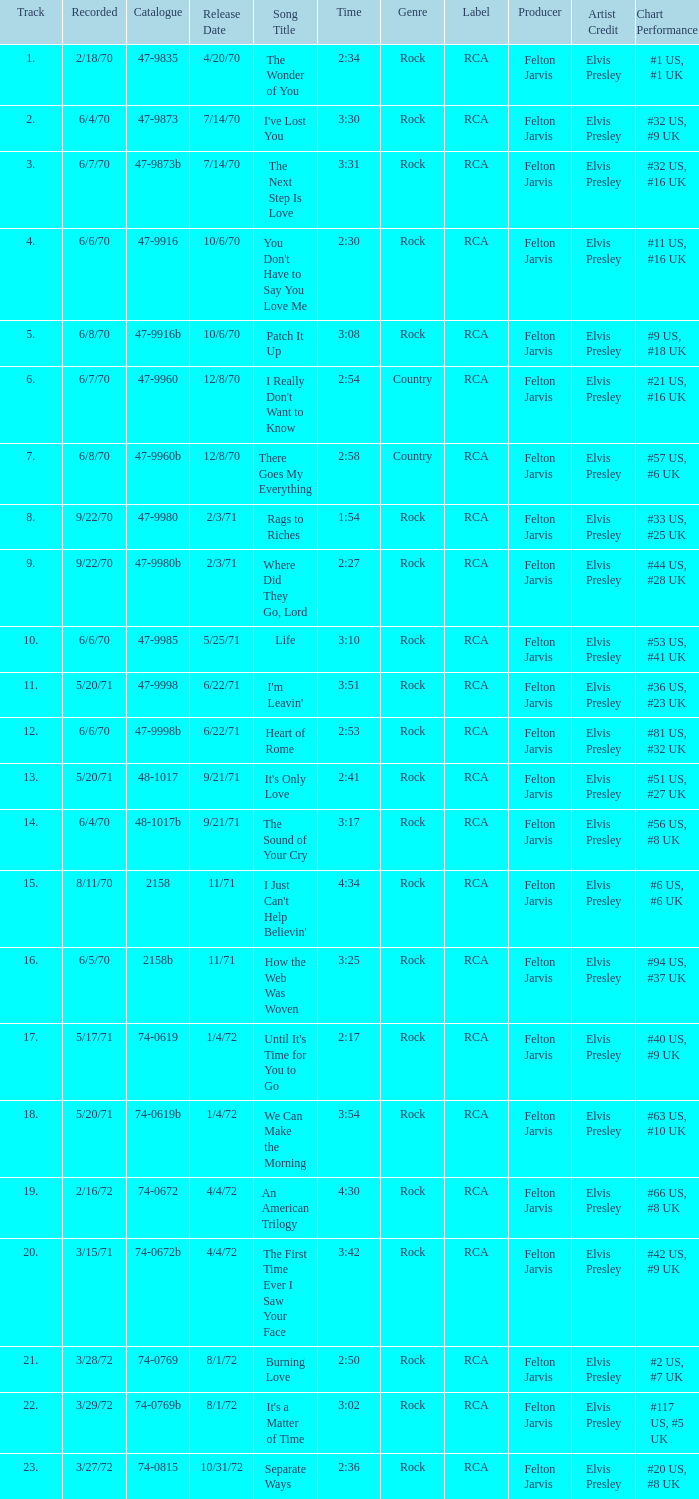What is Heart of Rome's catalogue number? 47-9998b. 